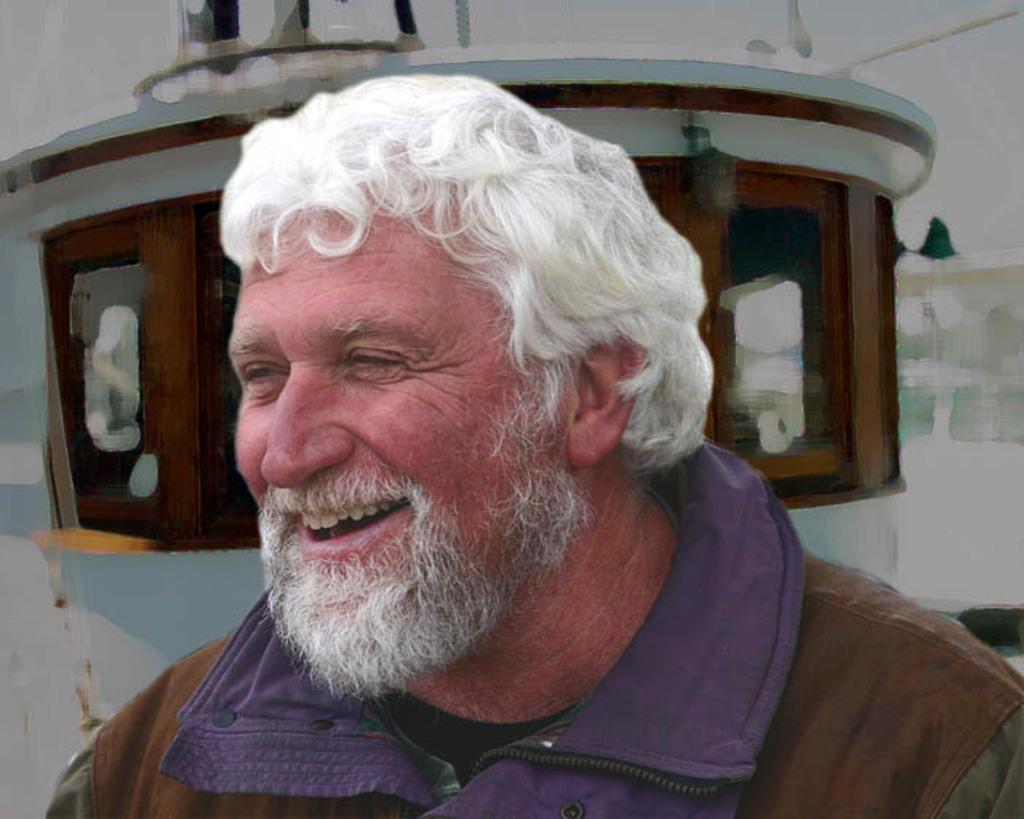Who is the main subject in the image? There is a man in the center of the image. What can be seen in the background of the image? There appears to be a poster in the background of the image. What historical event is depicted on the man's head in the image? There is no historical event depicted on the man's head in the image, as the facts provided do not mention anything about the man's head or any historical events. 